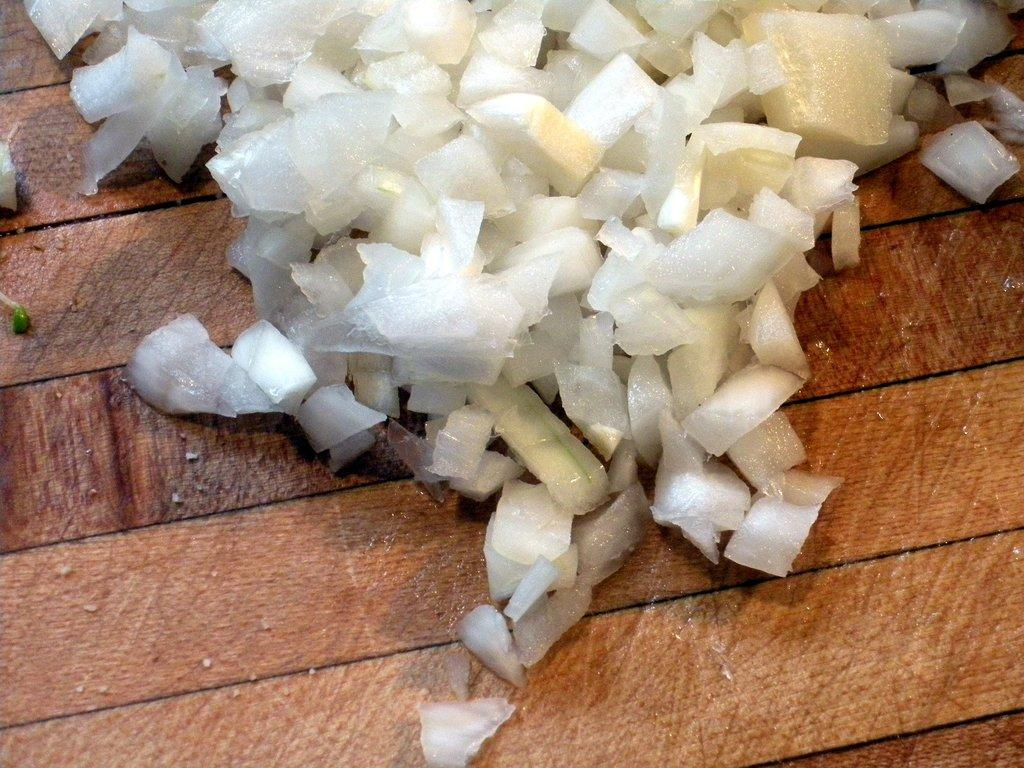What type of food item is visible in the image? There are chopped onions in the image. What color are the chopped onions? The chopped onions are white in color. What type of surface is the chopped onions placed on? There is a wooden table in the image. What color is the wooden table? The wooden table is brown in color. What channel is the fear being broadcasted on in the image? There is no reference to a channel or fear in the image, as it features chopped onions on a wooden table. 